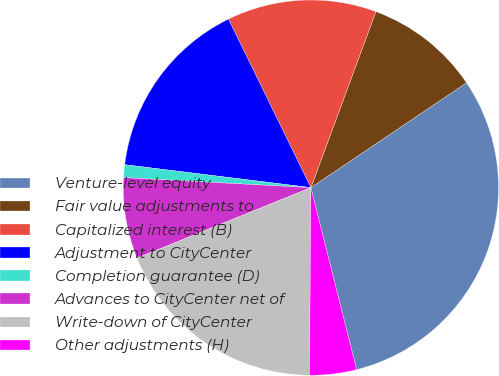<chart> <loc_0><loc_0><loc_500><loc_500><pie_chart><fcel>Venture-level equity<fcel>Fair value adjustments to<fcel>Capitalized interest (B)<fcel>Adjustment to CityCenter<fcel>Completion guarantee (D)<fcel>Advances to CityCenter net of<fcel>Write-down of CityCenter<fcel>Other adjustments (H)<nl><fcel>30.52%<fcel>9.93%<fcel>12.87%<fcel>15.81%<fcel>1.1%<fcel>6.98%<fcel>18.75%<fcel>4.04%<nl></chart> 